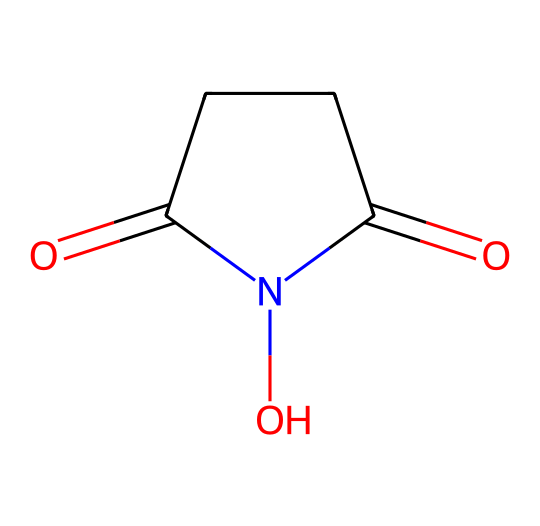What is the molecular formula of N-hydroxysuccinimide? The molecular formula can be determined by counting the atoms in the structure. The SMILES representation indicates one nitrogen (N), four carbons (C), five hydrogens (H), and three oxygens (O). Combining these gives the molecular formula C4H5NO3.
Answer: C4H5NO3 How many oxygen atoms are present in this chemical? From the molecular structure represented in the SMILES, we can see that there are three oxygen atoms indicated by 'O' occurrences. Therefore, the number of oxygen atoms is three.
Answer: 3 What functional groups are present in N-hydroxysuccinimide? The structure contains a hydroxyl group (-OH) and a carbonyl group (C=O), which together indicate that it is an imide. The presence of both groups defines its functional composition.
Answer: hydroxyl and carbonyl groups What type of reaction is N-hydroxysuccinimide primarily used for in organic synthesis? N-hydroxysuccinimide is commonly used as a reagent in the synthesis of amides, which involves the formation of covalent bonds with amino groups.
Answer: amide formation How does the nitrogen atom's presence affect the reactivity of N-hydroxysuccinimide? The nitrogen atom contributes to the molecule's ability to act as a nucleophile and participate in various reactions. This is typical for nitrogen in heterocyclic compounds, increasing its reactivity in organic synthesis.
Answer: increases reactivity What is the IUPAC name for N-hydroxysuccinimide? The IUPAC name can be derived by analyzing the structure; it is named based on the imide functional group and the hydroxyl functionality, identified as N-hydroxysuccinimide.
Answer: N-hydroxysuccinimide 